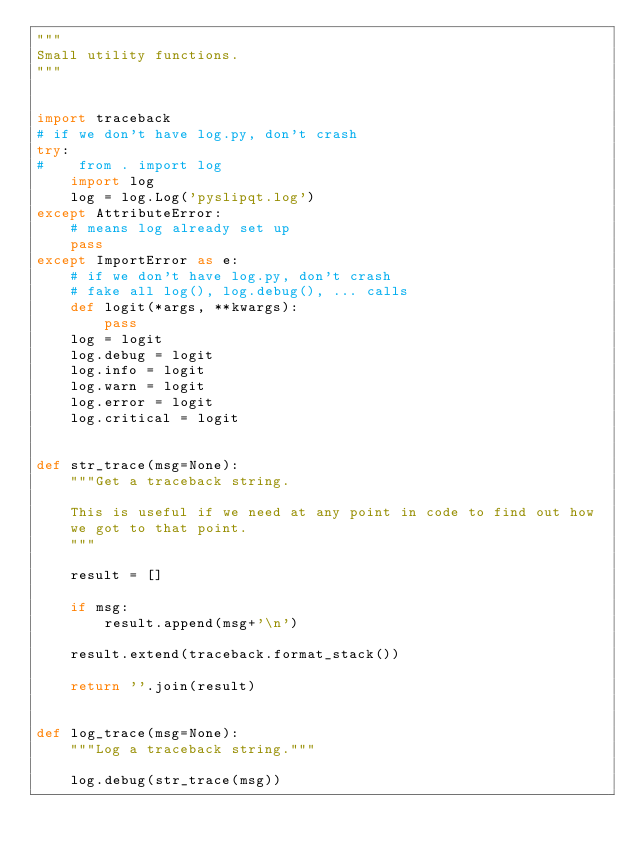<code> <loc_0><loc_0><loc_500><loc_500><_Python_>"""
Small utility functions.
"""


import traceback
# if we don't have log.py, don't crash
try:
#    from . import log
    import log
    log = log.Log('pyslipqt.log')
except AttributeError:
    # means log already set up
    pass
except ImportError as e:
    # if we don't have log.py, don't crash
    # fake all log(), log.debug(), ... calls
    def logit(*args, **kwargs):
        pass
    log = logit
    log.debug = logit
    log.info = logit
    log.warn = logit
    log.error = logit
    log.critical = logit


def str_trace(msg=None):
    """Get a traceback string.

    This is useful if we need at any point in code to find out how
    we got to that point.
    """

    result = []

    if msg:
        result.append(msg+'\n')

    result.extend(traceback.format_stack())

    return ''.join(result)


def log_trace(msg=None):
    """Log a traceback string."""

    log.debug(str_trace(msg))
</code> 